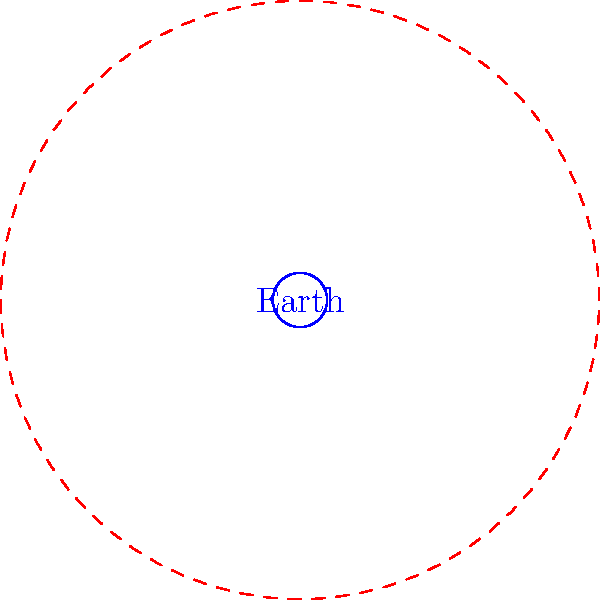In the diagram, Earth and Jupiter are represented by circles. The radius of Jupiter's circle is 11 times that of Earth's. If we consider the volume of a sphere to be proportional to the cube of its radius, approximately how many times greater is Jupiter's volume compared to Earth's? To solve this problem, let's follow these steps:

1) We know that the volume of a sphere is proportional to the cube of its radius. The formula is:

   $V = \frac{4}{3}\pi r^3$

2) Let's denote Earth's radius as $R_E$ and Jupiter's radius as $R_J$. We're told that $R_J = 11R_E$.

3) Now, let's set up the ratio of their volumes:

   $\frac{V_J}{V_E} = \frac{\frac{4}{3}\pi R_J^3}{\frac{4}{3}\pi R_E^3}$

4) The $\frac{4}{3}\pi$ cancels out, leaving us with:

   $\frac{V_J}{V_E} = \frac{R_J^3}{R_E^3}$

5) We know $R_J = 11R_E$, so let's substitute:

   $\frac{V_J}{V_E} = \frac{(11R_E)^3}{R_E^3} = \frac{1331R_E^3}{R_E^3} = 1331$

6) Therefore, Jupiter's volume is 1331 times greater than Earth's volume.

This problem illustrates how small differences in radius can lead to large differences in volume for spherical objects, which is relevant to understanding the vast size differences between planets in our solar system.
Answer: 1331 times 